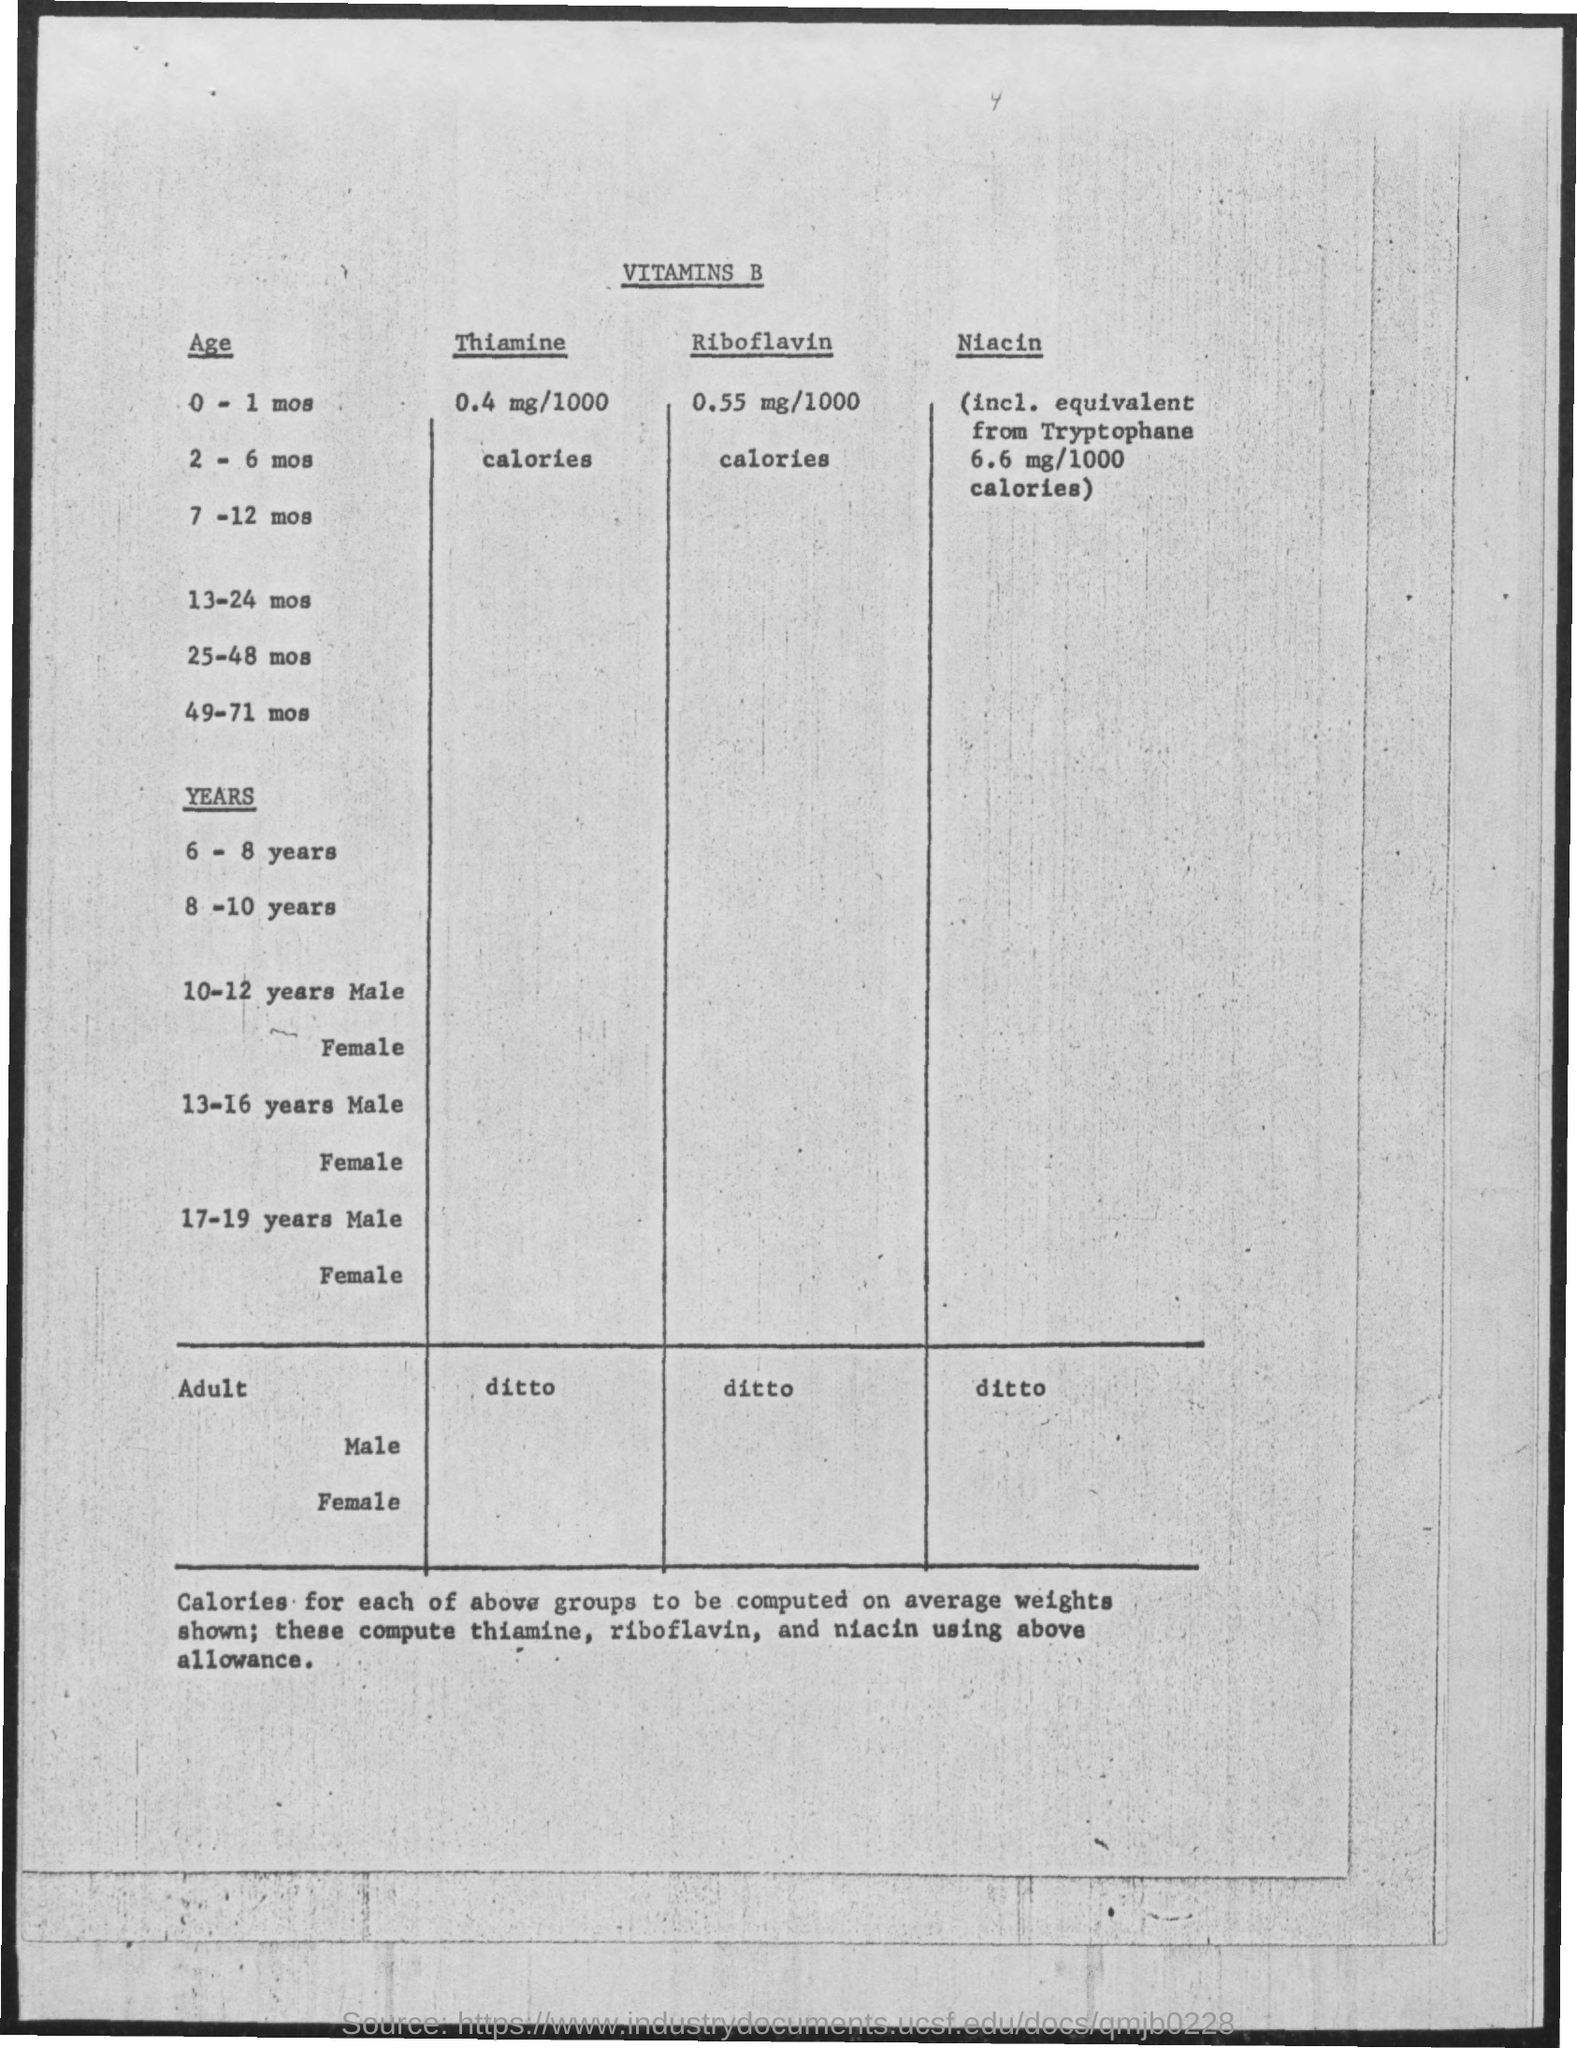What is the first title in the document?
Give a very brief answer. Vitamins b. What is the second column name?
Keep it short and to the point. Thiamine. 